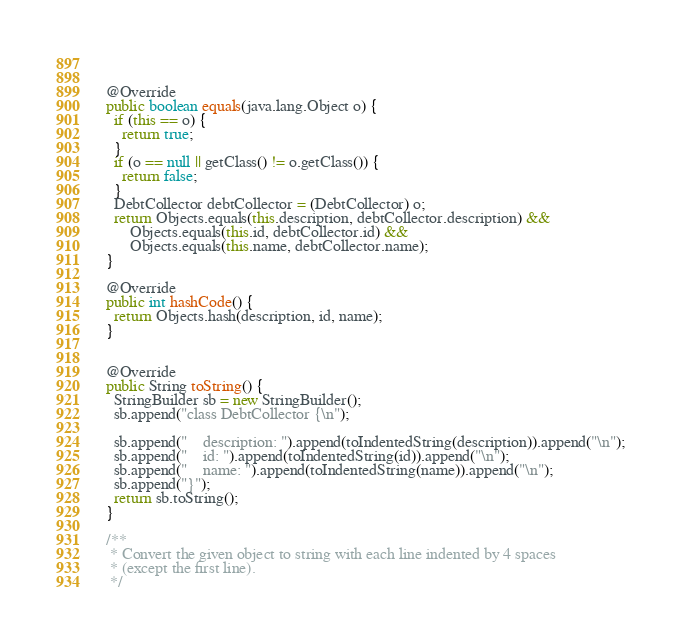Convert code to text. <code><loc_0><loc_0><loc_500><loc_500><_Java_>
  

  @Override
  public boolean equals(java.lang.Object o) {
    if (this == o) {
      return true;
    }
    if (o == null || getClass() != o.getClass()) {
      return false;
    }
    DebtCollector debtCollector = (DebtCollector) o;
    return Objects.equals(this.description, debtCollector.description) &&
        Objects.equals(this.id, debtCollector.id) &&
        Objects.equals(this.name, debtCollector.name);
  }

  @Override
  public int hashCode() {
    return Objects.hash(description, id, name);
  }


  @Override
  public String toString() {
    StringBuilder sb = new StringBuilder();
    sb.append("class DebtCollector {\n");
    
    sb.append("    description: ").append(toIndentedString(description)).append("\n");
    sb.append("    id: ").append(toIndentedString(id)).append("\n");
    sb.append("    name: ").append(toIndentedString(name)).append("\n");
    sb.append("}");
    return sb.toString();
  }

  /**
   * Convert the given object to string with each line indented by 4 spaces
   * (except the first line).
   */</code> 